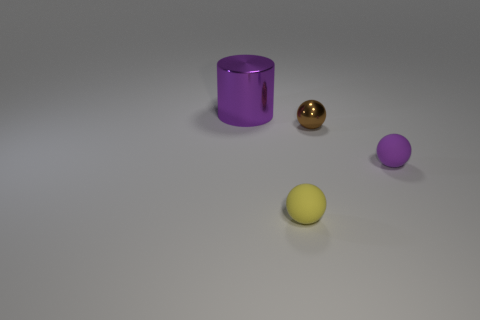Subtract all small rubber spheres. How many spheres are left? 1 Subtract all yellow balls. How many balls are left? 2 Add 1 large green cubes. How many objects exist? 5 Subtract all balls. How many objects are left? 1 Subtract 2 spheres. How many spheres are left? 1 Add 4 tiny blue spheres. How many tiny blue spheres exist? 4 Subtract 1 yellow spheres. How many objects are left? 3 Subtract all cyan cylinders. Subtract all purple balls. How many cylinders are left? 1 Subtract all yellow balls. How many gray cylinders are left? 0 Subtract all small gray matte balls. Subtract all tiny shiny things. How many objects are left? 3 